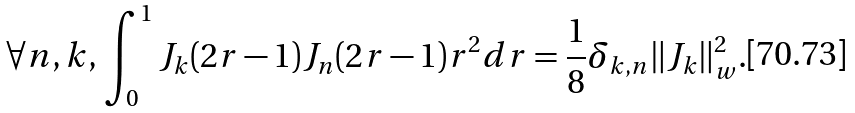Convert formula to latex. <formula><loc_0><loc_0><loc_500><loc_500>\forall n , k , \, \int _ { 0 } ^ { 1 } J _ { k } ( 2 r - 1 ) J _ { n } ( 2 r - 1 ) r ^ { 2 } d r = \frac { 1 } { 8 } \delta _ { k , n } \| J _ { k } \| _ { w } ^ { 2 } .</formula> 